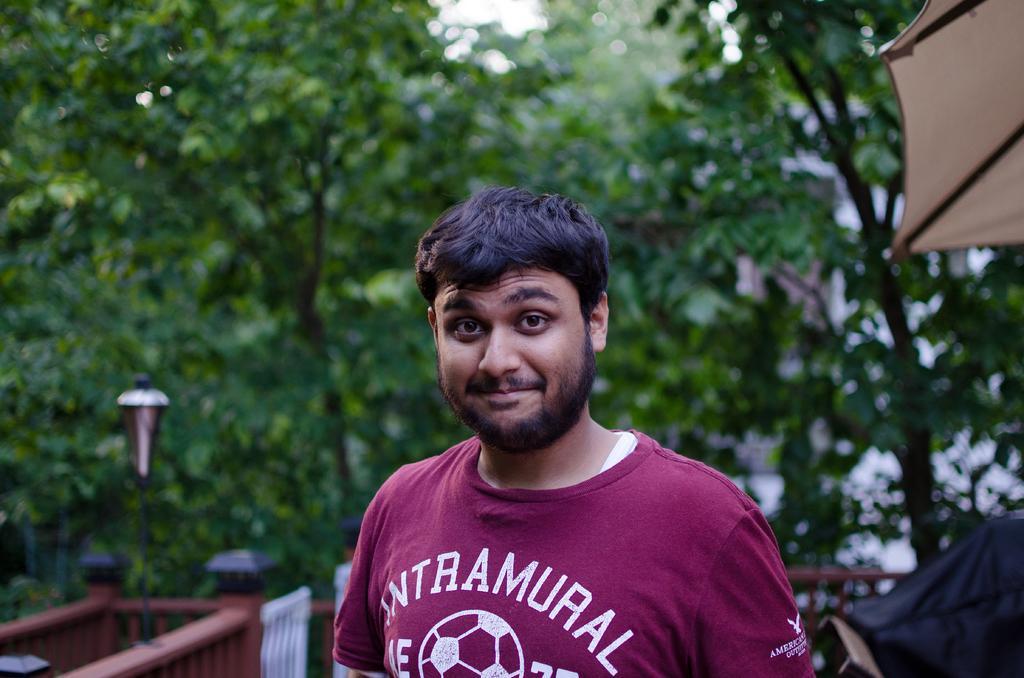Please provide a concise description of this image. Here I can see a man wearing a t-shirt, smiling and looking at the picture. In the background there is a railing and a light pole. In the background there are many trees. In the top right-hand corner there is an umbrella. 